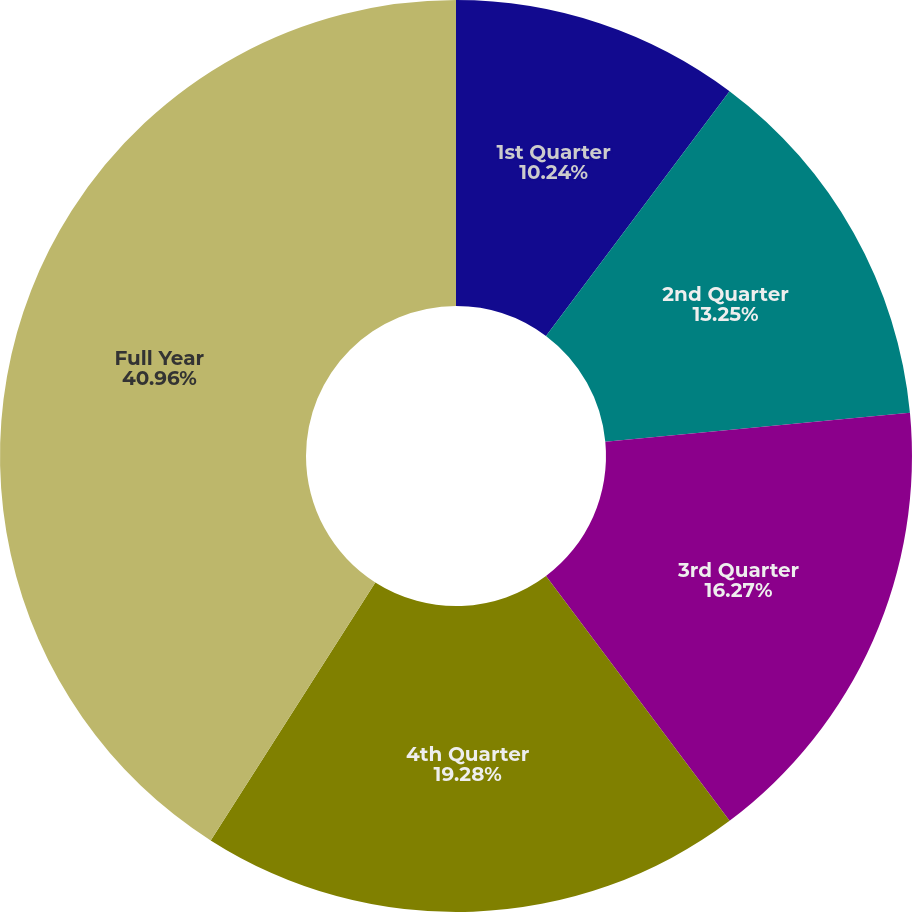Convert chart. <chart><loc_0><loc_0><loc_500><loc_500><pie_chart><fcel>1st Quarter<fcel>2nd Quarter<fcel>3rd Quarter<fcel>4th Quarter<fcel>Full Year<nl><fcel>10.24%<fcel>13.25%<fcel>16.27%<fcel>19.28%<fcel>40.96%<nl></chart> 